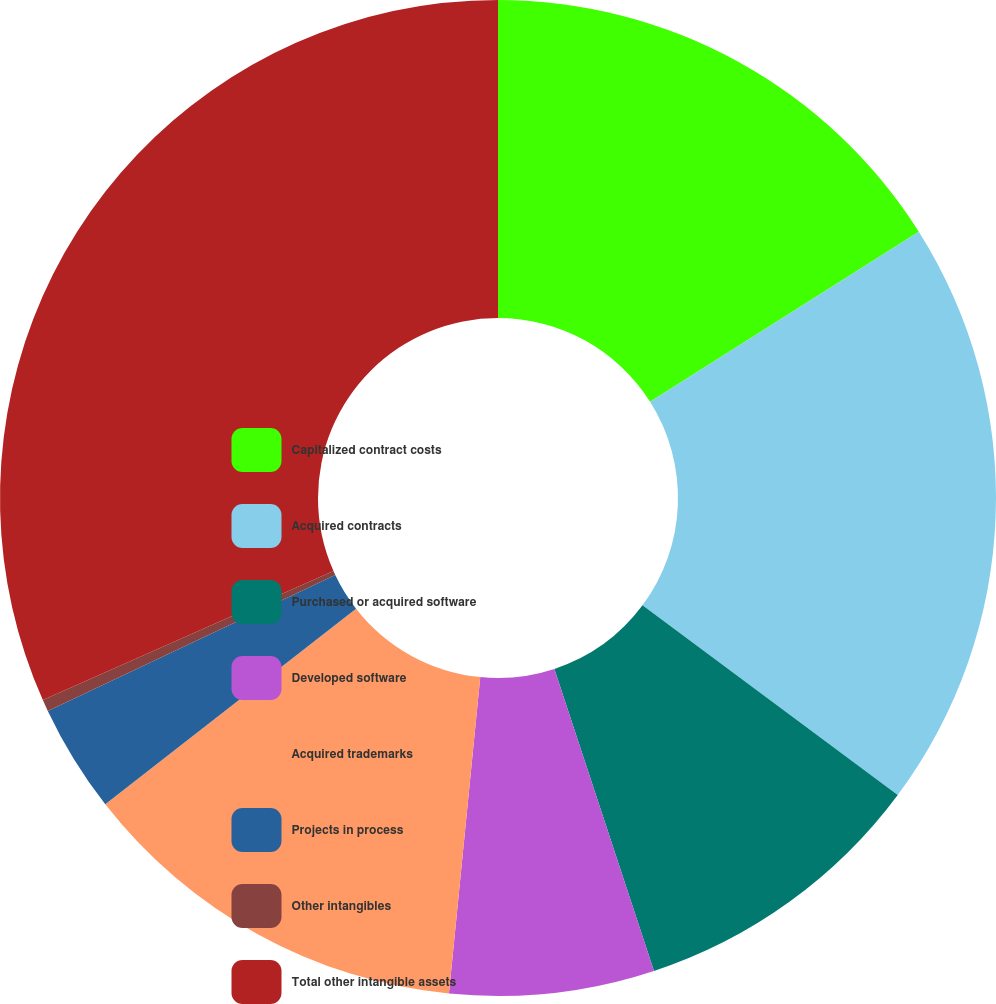Convert chart to OTSL. <chart><loc_0><loc_0><loc_500><loc_500><pie_chart><fcel>Capitalized contract costs<fcel>Acquired contracts<fcel>Purchased or acquired software<fcel>Developed software<fcel>Acquired trademarks<fcel>Projects in process<fcel>Other intangibles<fcel>Total other intangible assets<nl><fcel>16.02%<fcel>19.15%<fcel>9.76%<fcel>6.64%<fcel>12.89%<fcel>3.51%<fcel>0.38%<fcel>31.65%<nl></chart> 